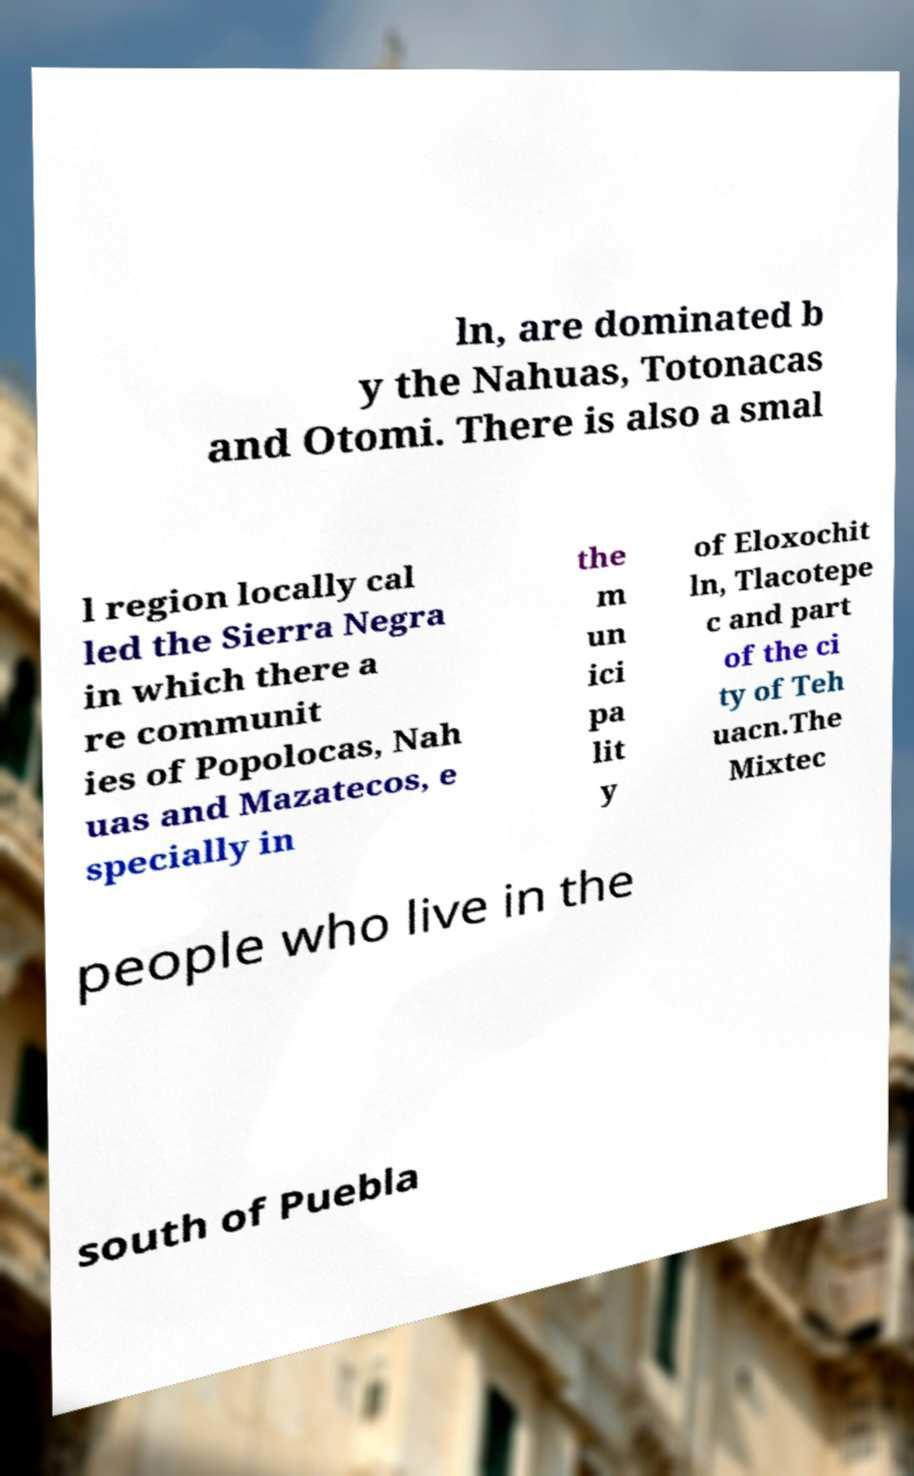I need the written content from this picture converted into text. Can you do that? ln, are dominated b y the Nahuas, Totonacas and Otomi. There is also a smal l region locally cal led the Sierra Negra in which there a re communit ies of Popolocas, Nah uas and Mazatecos, e specially in the m un ici pa lit y of Eloxochit ln, Tlacotepe c and part of the ci ty of Teh uacn.The Mixtec people who live in the south of Puebla 